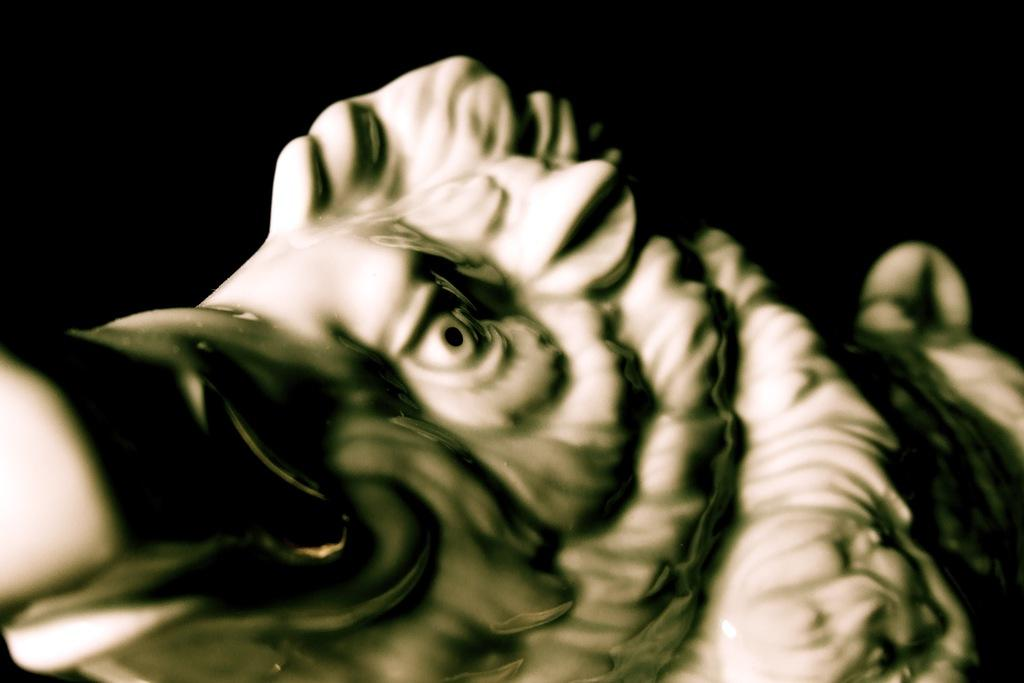What is the main subject of the image? The main subject of the image is a statue. What type of statue is it? The statue is of an animal. What color is the statue? The statue is in white color. How would you describe the background of the image? The background of the image is dark. Can you tell me how many visitors are swimming around the statue in the image? There are no visitors or swimming activity depicted in the image; it only features a white statue of an animal against a dark background. 